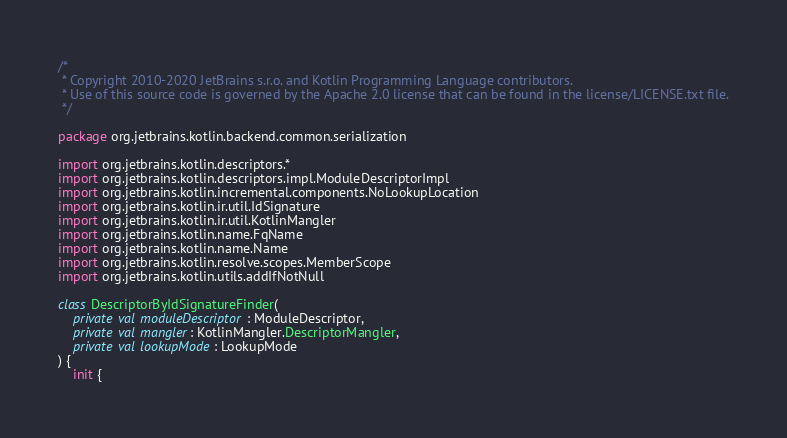Convert code to text. <code><loc_0><loc_0><loc_500><loc_500><_Kotlin_>/*
 * Copyright 2010-2020 JetBrains s.r.o. and Kotlin Programming Language contributors.
 * Use of this source code is governed by the Apache 2.0 license that can be found in the license/LICENSE.txt file.
 */

package org.jetbrains.kotlin.backend.common.serialization

import org.jetbrains.kotlin.descriptors.*
import org.jetbrains.kotlin.descriptors.impl.ModuleDescriptorImpl
import org.jetbrains.kotlin.incremental.components.NoLookupLocation
import org.jetbrains.kotlin.ir.util.IdSignature
import org.jetbrains.kotlin.ir.util.KotlinMangler
import org.jetbrains.kotlin.name.FqName
import org.jetbrains.kotlin.name.Name
import org.jetbrains.kotlin.resolve.scopes.MemberScope
import org.jetbrains.kotlin.utils.addIfNotNull

class DescriptorByIdSignatureFinder(
    private val moduleDescriptor: ModuleDescriptor,
    private val mangler: KotlinMangler.DescriptorMangler,
    private val lookupMode: LookupMode
) {
    init {</code> 